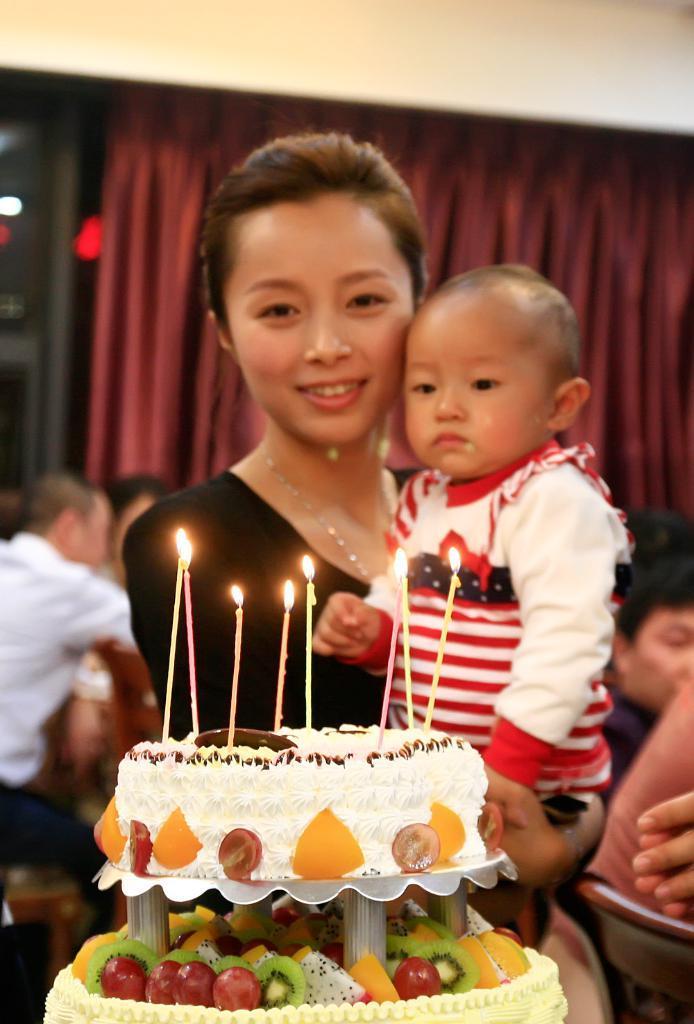In one or two sentences, can you explain what this image depicts? This is the picture of a lady who is holding the kid and standing in front of the cake on which there are some fruits, candles and behind there are some other people and a curtain to the wall. 